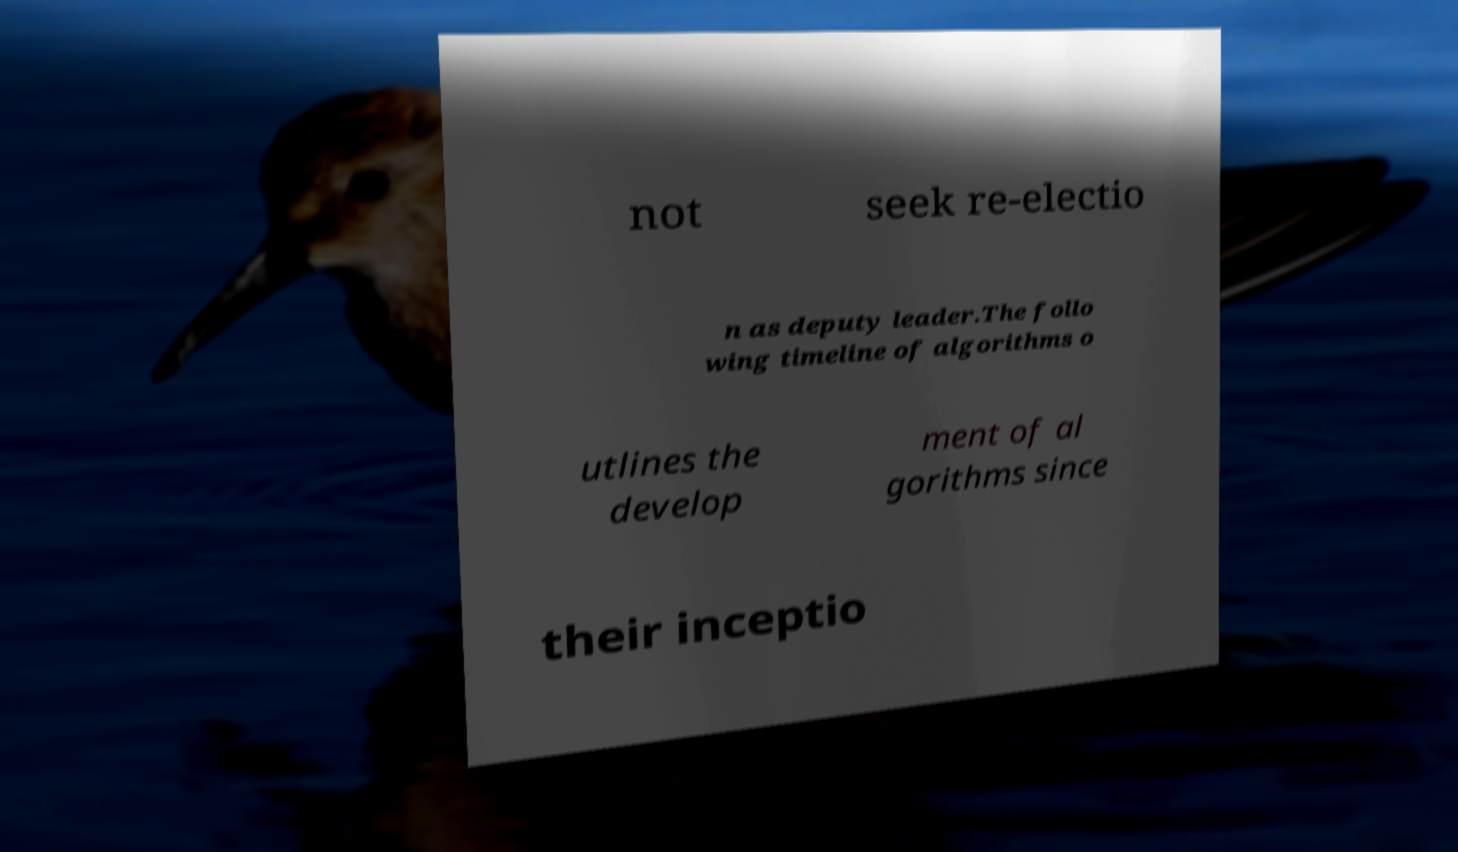What messages or text are displayed in this image? I need them in a readable, typed format. not seek re-electio n as deputy leader.The follo wing timeline of algorithms o utlines the develop ment of al gorithms since their inceptio 